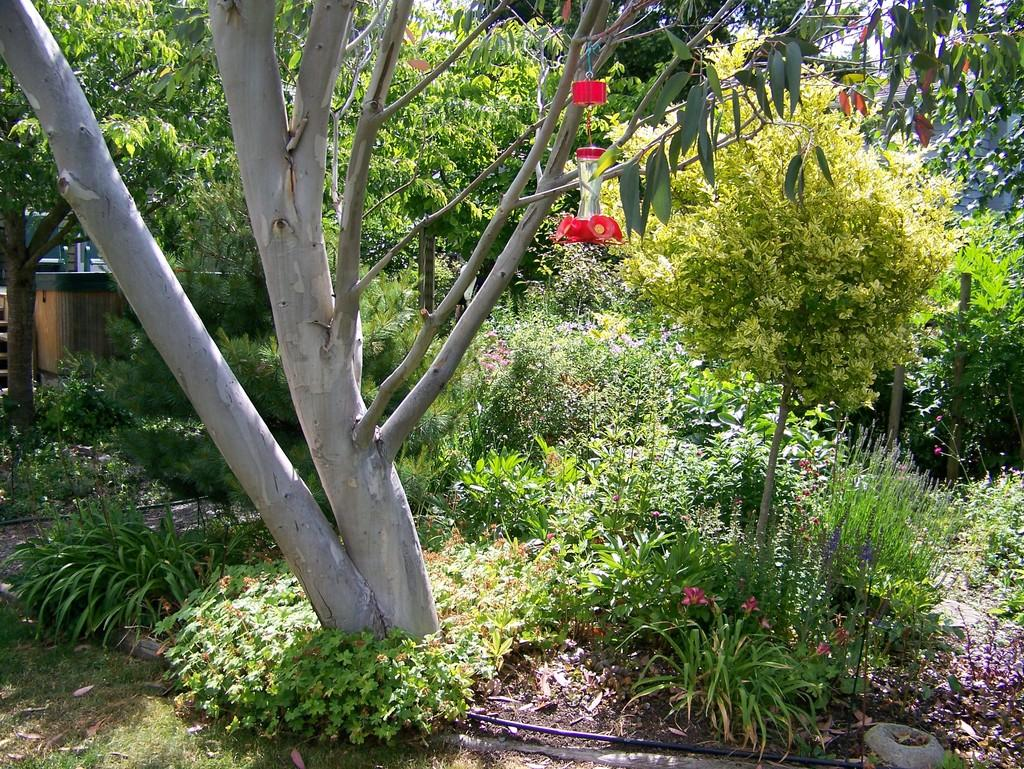What type of area is depicted in the image? There is a garden area in the image. What can be found in the garden area? There are many trees, plants, and flowers in the garden area. What type of cheese is being used to fertilize the plants in the garden area? There is no cheese present in the image, and it is not being used to fertilize the plants. 